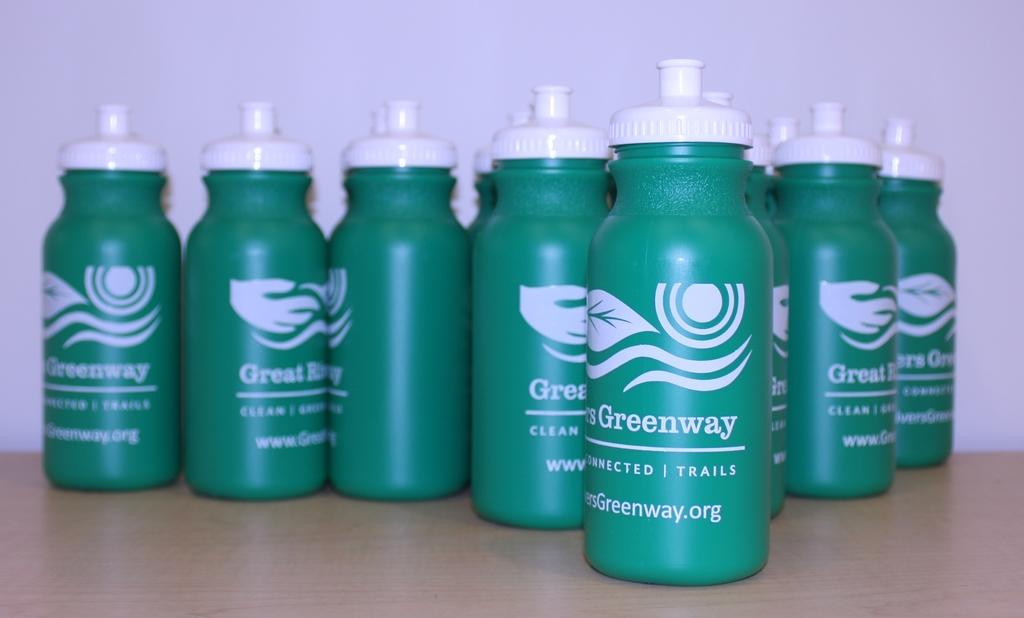Provide a one-sentence caption for the provided image. Green water bottle with the word Greenway on them sit on a surface. 